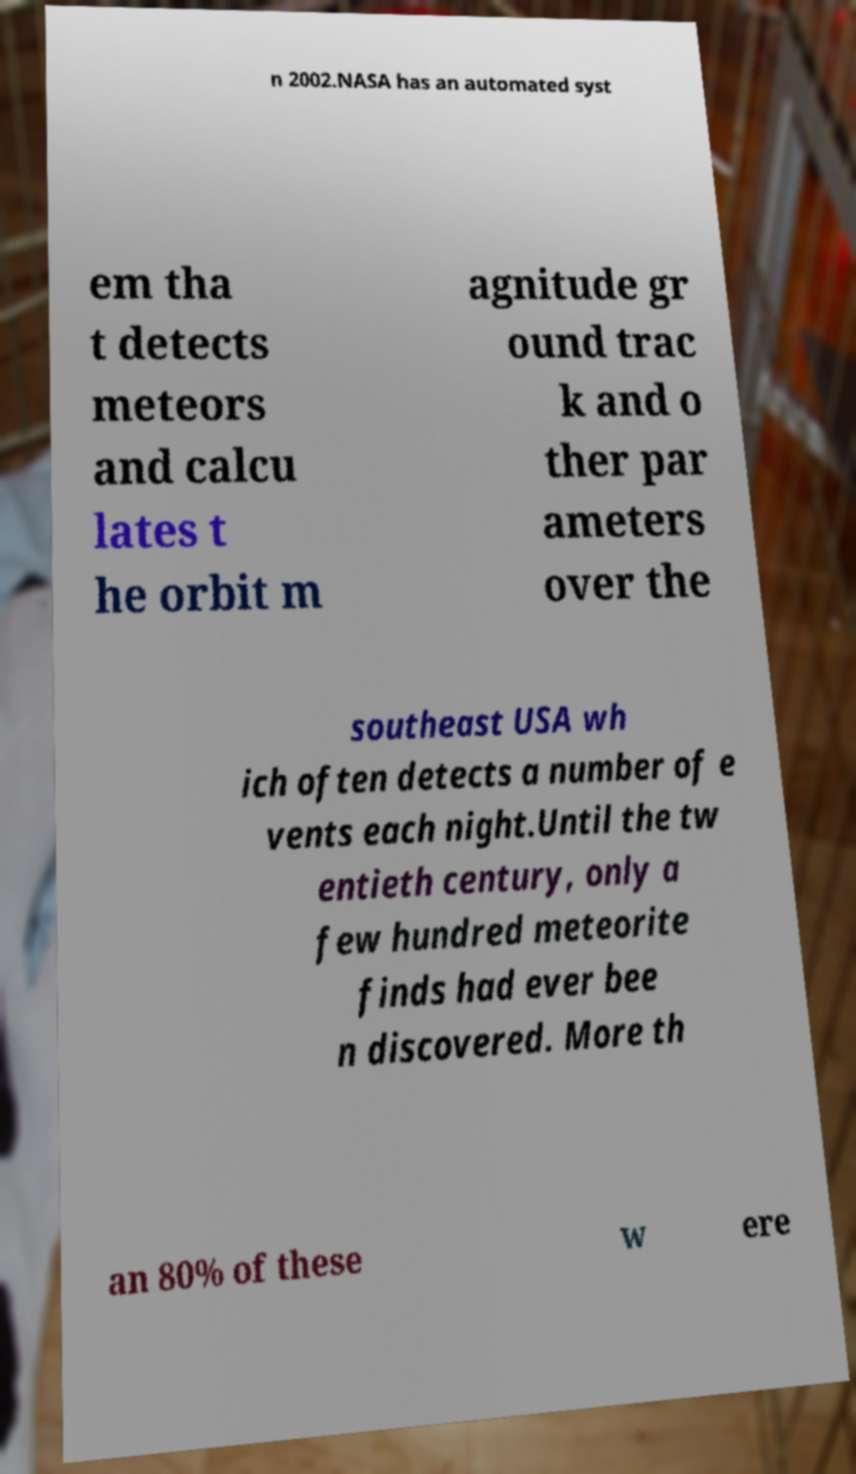What messages or text are displayed in this image? I need them in a readable, typed format. n 2002.NASA has an automated syst em tha t detects meteors and calcu lates t he orbit m agnitude gr ound trac k and o ther par ameters over the southeast USA wh ich often detects a number of e vents each night.Until the tw entieth century, only a few hundred meteorite finds had ever bee n discovered. More th an 80% of these w ere 